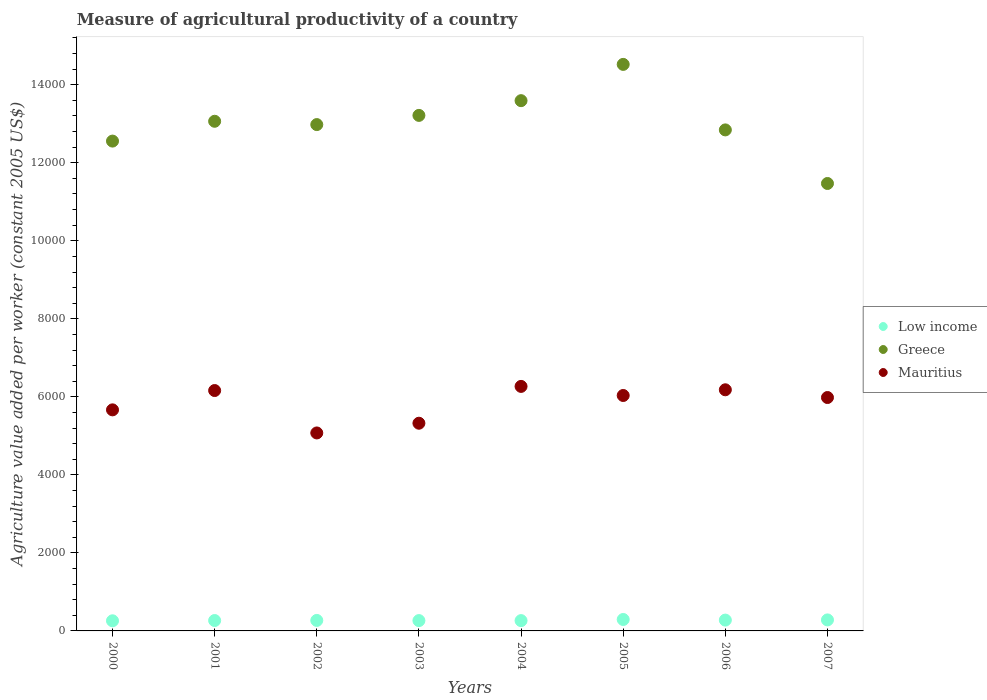How many different coloured dotlines are there?
Provide a succinct answer. 3. What is the measure of agricultural productivity in Low income in 2003?
Your answer should be very brief. 264.83. Across all years, what is the maximum measure of agricultural productivity in Mauritius?
Ensure brevity in your answer.  6267.78. Across all years, what is the minimum measure of agricultural productivity in Mauritius?
Offer a very short reply. 5074.63. In which year was the measure of agricultural productivity in Low income maximum?
Offer a very short reply. 2005. In which year was the measure of agricultural productivity in Mauritius minimum?
Your response must be concise. 2002. What is the total measure of agricultural productivity in Low income in the graph?
Offer a very short reply. 2176.02. What is the difference between the measure of agricultural productivity in Mauritius in 2003 and that in 2004?
Make the answer very short. -943.74. What is the difference between the measure of agricultural productivity in Low income in 2004 and the measure of agricultural productivity in Greece in 2002?
Give a very brief answer. -1.27e+04. What is the average measure of agricultural productivity in Low income per year?
Offer a very short reply. 272. In the year 2004, what is the difference between the measure of agricultural productivity in Mauritius and measure of agricultural productivity in Low income?
Give a very brief answer. 6003.74. What is the ratio of the measure of agricultural productivity in Low income in 2003 to that in 2007?
Give a very brief answer. 0.94. Is the measure of agricultural productivity in Mauritius in 2001 less than that in 2004?
Your answer should be very brief. Yes. Is the difference between the measure of agricultural productivity in Mauritius in 2003 and 2004 greater than the difference between the measure of agricultural productivity in Low income in 2003 and 2004?
Give a very brief answer. No. What is the difference between the highest and the second highest measure of agricultural productivity in Mauritius?
Ensure brevity in your answer.  86.66. What is the difference between the highest and the lowest measure of agricultural productivity in Greece?
Your answer should be very brief. 3052.71. Is the sum of the measure of agricultural productivity in Greece in 2003 and 2006 greater than the maximum measure of agricultural productivity in Mauritius across all years?
Offer a terse response. Yes. Is the measure of agricultural productivity in Low income strictly less than the measure of agricultural productivity in Greece over the years?
Offer a terse response. Yes. How many years are there in the graph?
Provide a short and direct response. 8. Are the values on the major ticks of Y-axis written in scientific E-notation?
Make the answer very short. No. Does the graph contain any zero values?
Offer a terse response. No. Does the graph contain grids?
Provide a succinct answer. No. How are the legend labels stacked?
Ensure brevity in your answer.  Vertical. What is the title of the graph?
Ensure brevity in your answer.  Measure of agricultural productivity of a country. What is the label or title of the Y-axis?
Provide a succinct answer. Agriculture value added per worker (constant 2005 US$). What is the Agriculture value added per worker (constant 2005 US$) of Low income in 2000?
Offer a very short reply. 259.54. What is the Agriculture value added per worker (constant 2005 US$) in Greece in 2000?
Offer a very short reply. 1.26e+04. What is the Agriculture value added per worker (constant 2005 US$) of Mauritius in 2000?
Offer a very short reply. 5666.66. What is the Agriculture value added per worker (constant 2005 US$) in Low income in 2001?
Keep it short and to the point. 266.17. What is the Agriculture value added per worker (constant 2005 US$) of Greece in 2001?
Keep it short and to the point. 1.31e+04. What is the Agriculture value added per worker (constant 2005 US$) in Mauritius in 2001?
Offer a terse response. 6161.82. What is the Agriculture value added per worker (constant 2005 US$) of Low income in 2002?
Your answer should be compact. 268.98. What is the Agriculture value added per worker (constant 2005 US$) in Greece in 2002?
Your response must be concise. 1.30e+04. What is the Agriculture value added per worker (constant 2005 US$) of Mauritius in 2002?
Ensure brevity in your answer.  5074.63. What is the Agriculture value added per worker (constant 2005 US$) of Low income in 2003?
Keep it short and to the point. 264.83. What is the Agriculture value added per worker (constant 2005 US$) of Greece in 2003?
Offer a terse response. 1.32e+04. What is the Agriculture value added per worker (constant 2005 US$) of Mauritius in 2003?
Your response must be concise. 5324.04. What is the Agriculture value added per worker (constant 2005 US$) of Low income in 2004?
Keep it short and to the point. 264.04. What is the Agriculture value added per worker (constant 2005 US$) in Greece in 2004?
Keep it short and to the point. 1.36e+04. What is the Agriculture value added per worker (constant 2005 US$) of Mauritius in 2004?
Give a very brief answer. 6267.78. What is the Agriculture value added per worker (constant 2005 US$) in Low income in 2005?
Make the answer very short. 292.99. What is the Agriculture value added per worker (constant 2005 US$) in Greece in 2005?
Your answer should be very brief. 1.45e+04. What is the Agriculture value added per worker (constant 2005 US$) in Mauritius in 2005?
Keep it short and to the point. 6034.91. What is the Agriculture value added per worker (constant 2005 US$) of Low income in 2006?
Provide a short and direct response. 277.44. What is the Agriculture value added per worker (constant 2005 US$) in Greece in 2006?
Keep it short and to the point. 1.28e+04. What is the Agriculture value added per worker (constant 2005 US$) of Mauritius in 2006?
Make the answer very short. 6181.12. What is the Agriculture value added per worker (constant 2005 US$) of Low income in 2007?
Make the answer very short. 282.02. What is the Agriculture value added per worker (constant 2005 US$) in Greece in 2007?
Ensure brevity in your answer.  1.15e+04. What is the Agriculture value added per worker (constant 2005 US$) of Mauritius in 2007?
Offer a very short reply. 5982.86. Across all years, what is the maximum Agriculture value added per worker (constant 2005 US$) of Low income?
Your response must be concise. 292.99. Across all years, what is the maximum Agriculture value added per worker (constant 2005 US$) of Greece?
Offer a very short reply. 1.45e+04. Across all years, what is the maximum Agriculture value added per worker (constant 2005 US$) of Mauritius?
Your answer should be compact. 6267.78. Across all years, what is the minimum Agriculture value added per worker (constant 2005 US$) of Low income?
Offer a very short reply. 259.54. Across all years, what is the minimum Agriculture value added per worker (constant 2005 US$) of Greece?
Your answer should be compact. 1.15e+04. Across all years, what is the minimum Agriculture value added per worker (constant 2005 US$) of Mauritius?
Offer a very short reply. 5074.63. What is the total Agriculture value added per worker (constant 2005 US$) in Low income in the graph?
Ensure brevity in your answer.  2176.02. What is the total Agriculture value added per worker (constant 2005 US$) in Greece in the graph?
Make the answer very short. 1.04e+05. What is the total Agriculture value added per worker (constant 2005 US$) in Mauritius in the graph?
Keep it short and to the point. 4.67e+04. What is the difference between the Agriculture value added per worker (constant 2005 US$) in Low income in 2000 and that in 2001?
Provide a short and direct response. -6.64. What is the difference between the Agriculture value added per worker (constant 2005 US$) of Greece in 2000 and that in 2001?
Your response must be concise. -507.92. What is the difference between the Agriculture value added per worker (constant 2005 US$) in Mauritius in 2000 and that in 2001?
Offer a very short reply. -495.15. What is the difference between the Agriculture value added per worker (constant 2005 US$) in Low income in 2000 and that in 2002?
Offer a very short reply. -9.45. What is the difference between the Agriculture value added per worker (constant 2005 US$) in Greece in 2000 and that in 2002?
Offer a terse response. -423.05. What is the difference between the Agriculture value added per worker (constant 2005 US$) of Mauritius in 2000 and that in 2002?
Give a very brief answer. 592.03. What is the difference between the Agriculture value added per worker (constant 2005 US$) in Low income in 2000 and that in 2003?
Offer a terse response. -5.3. What is the difference between the Agriculture value added per worker (constant 2005 US$) of Greece in 2000 and that in 2003?
Your response must be concise. -658.71. What is the difference between the Agriculture value added per worker (constant 2005 US$) of Mauritius in 2000 and that in 2003?
Your answer should be very brief. 342.62. What is the difference between the Agriculture value added per worker (constant 2005 US$) in Low income in 2000 and that in 2004?
Offer a terse response. -4.5. What is the difference between the Agriculture value added per worker (constant 2005 US$) in Greece in 2000 and that in 2004?
Offer a very short reply. -1036.19. What is the difference between the Agriculture value added per worker (constant 2005 US$) of Mauritius in 2000 and that in 2004?
Offer a very short reply. -601.12. What is the difference between the Agriculture value added per worker (constant 2005 US$) in Low income in 2000 and that in 2005?
Keep it short and to the point. -33.46. What is the difference between the Agriculture value added per worker (constant 2005 US$) in Greece in 2000 and that in 2005?
Offer a very short reply. -1965.98. What is the difference between the Agriculture value added per worker (constant 2005 US$) of Mauritius in 2000 and that in 2005?
Your answer should be very brief. -368.25. What is the difference between the Agriculture value added per worker (constant 2005 US$) of Low income in 2000 and that in 2006?
Provide a short and direct response. -17.9. What is the difference between the Agriculture value added per worker (constant 2005 US$) of Greece in 2000 and that in 2006?
Offer a very short reply. -286.79. What is the difference between the Agriculture value added per worker (constant 2005 US$) in Mauritius in 2000 and that in 2006?
Offer a terse response. -514.46. What is the difference between the Agriculture value added per worker (constant 2005 US$) in Low income in 2000 and that in 2007?
Your answer should be compact. -22.49. What is the difference between the Agriculture value added per worker (constant 2005 US$) in Greece in 2000 and that in 2007?
Your answer should be compact. 1086.73. What is the difference between the Agriculture value added per worker (constant 2005 US$) in Mauritius in 2000 and that in 2007?
Give a very brief answer. -316.19. What is the difference between the Agriculture value added per worker (constant 2005 US$) in Low income in 2001 and that in 2002?
Provide a succinct answer. -2.81. What is the difference between the Agriculture value added per worker (constant 2005 US$) of Greece in 2001 and that in 2002?
Provide a short and direct response. 84.86. What is the difference between the Agriculture value added per worker (constant 2005 US$) in Mauritius in 2001 and that in 2002?
Keep it short and to the point. 1087.19. What is the difference between the Agriculture value added per worker (constant 2005 US$) of Low income in 2001 and that in 2003?
Offer a terse response. 1.34. What is the difference between the Agriculture value added per worker (constant 2005 US$) in Greece in 2001 and that in 2003?
Offer a terse response. -150.79. What is the difference between the Agriculture value added per worker (constant 2005 US$) of Mauritius in 2001 and that in 2003?
Give a very brief answer. 837.77. What is the difference between the Agriculture value added per worker (constant 2005 US$) of Low income in 2001 and that in 2004?
Your response must be concise. 2.13. What is the difference between the Agriculture value added per worker (constant 2005 US$) of Greece in 2001 and that in 2004?
Ensure brevity in your answer.  -528.27. What is the difference between the Agriculture value added per worker (constant 2005 US$) in Mauritius in 2001 and that in 2004?
Keep it short and to the point. -105.96. What is the difference between the Agriculture value added per worker (constant 2005 US$) of Low income in 2001 and that in 2005?
Offer a very short reply. -26.82. What is the difference between the Agriculture value added per worker (constant 2005 US$) of Greece in 2001 and that in 2005?
Provide a succinct answer. -1458.06. What is the difference between the Agriculture value added per worker (constant 2005 US$) in Mauritius in 2001 and that in 2005?
Ensure brevity in your answer.  126.91. What is the difference between the Agriculture value added per worker (constant 2005 US$) of Low income in 2001 and that in 2006?
Provide a succinct answer. -11.27. What is the difference between the Agriculture value added per worker (constant 2005 US$) in Greece in 2001 and that in 2006?
Ensure brevity in your answer.  221.12. What is the difference between the Agriculture value added per worker (constant 2005 US$) in Mauritius in 2001 and that in 2006?
Keep it short and to the point. -19.3. What is the difference between the Agriculture value added per worker (constant 2005 US$) of Low income in 2001 and that in 2007?
Your answer should be compact. -15.85. What is the difference between the Agriculture value added per worker (constant 2005 US$) of Greece in 2001 and that in 2007?
Make the answer very short. 1594.65. What is the difference between the Agriculture value added per worker (constant 2005 US$) of Mauritius in 2001 and that in 2007?
Give a very brief answer. 178.96. What is the difference between the Agriculture value added per worker (constant 2005 US$) in Low income in 2002 and that in 2003?
Your response must be concise. 4.15. What is the difference between the Agriculture value added per worker (constant 2005 US$) in Greece in 2002 and that in 2003?
Provide a short and direct response. -235.66. What is the difference between the Agriculture value added per worker (constant 2005 US$) in Mauritius in 2002 and that in 2003?
Provide a succinct answer. -249.41. What is the difference between the Agriculture value added per worker (constant 2005 US$) in Low income in 2002 and that in 2004?
Ensure brevity in your answer.  4.94. What is the difference between the Agriculture value added per worker (constant 2005 US$) of Greece in 2002 and that in 2004?
Your response must be concise. -613.14. What is the difference between the Agriculture value added per worker (constant 2005 US$) in Mauritius in 2002 and that in 2004?
Provide a short and direct response. -1193.15. What is the difference between the Agriculture value added per worker (constant 2005 US$) of Low income in 2002 and that in 2005?
Provide a short and direct response. -24.01. What is the difference between the Agriculture value added per worker (constant 2005 US$) in Greece in 2002 and that in 2005?
Ensure brevity in your answer.  -1542.93. What is the difference between the Agriculture value added per worker (constant 2005 US$) in Mauritius in 2002 and that in 2005?
Make the answer very short. -960.28. What is the difference between the Agriculture value added per worker (constant 2005 US$) of Low income in 2002 and that in 2006?
Give a very brief answer. -8.45. What is the difference between the Agriculture value added per worker (constant 2005 US$) in Greece in 2002 and that in 2006?
Your answer should be very brief. 136.26. What is the difference between the Agriculture value added per worker (constant 2005 US$) of Mauritius in 2002 and that in 2006?
Make the answer very short. -1106.49. What is the difference between the Agriculture value added per worker (constant 2005 US$) of Low income in 2002 and that in 2007?
Give a very brief answer. -13.04. What is the difference between the Agriculture value added per worker (constant 2005 US$) of Greece in 2002 and that in 2007?
Provide a short and direct response. 1509.79. What is the difference between the Agriculture value added per worker (constant 2005 US$) in Mauritius in 2002 and that in 2007?
Offer a terse response. -908.23. What is the difference between the Agriculture value added per worker (constant 2005 US$) of Low income in 2003 and that in 2004?
Provide a short and direct response. 0.79. What is the difference between the Agriculture value added per worker (constant 2005 US$) of Greece in 2003 and that in 2004?
Provide a succinct answer. -377.48. What is the difference between the Agriculture value added per worker (constant 2005 US$) in Mauritius in 2003 and that in 2004?
Offer a very short reply. -943.74. What is the difference between the Agriculture value added per worker (constant 2005 US$) of Low income in 2003 and that in 2005?
Provide a succinct answer. -28.16. What is the difference between the Agriculture value added per worker (constant 2005 US$) of Greece in 2003 and that in 2005?
Provide a succinct answer. -1307.27. What is the difference between the Agriculture value added per worker (constant 2005 US$) of Mauritius in 2003 and that in 2005?
Provide a succinct answer. -710.87. What is the difference between the Agriculture value added per worker (constant 2005 US$) of Low income in 2003 and that in 2006?
Your response must be concise. -12.6. What is the difference between the Agriculture value added per worker (constant 2005 US$) in Greece in 2003 and that in 2006?
Provide a succinct answer. 371.91. What is the difference between the Agriculture value added per worker (constant 2005 US$) in Mauritius in 2003 and that in 2006?
Ensure brevity in your answer.  -857.08. What is the difference between the Agriculture value added per worker (constant 2005 US$) in Low income in 2003 and that in 2007?
Provide a short and direct response. -17.19. What is the difference between the Agriculture value added per worker (constant 2005 US$) of Greece in 2003 and that in 2007?
Keep it short and to the point. 1745.44. What is the difference between the Agriculture value added per worker (constant 2005 US$) of Mauritius in 2003 and that in 2007?
Your answer should be compact. -658.81. What is the difference between the Agriculture value added per worker (constant 2005 US$) in Low income in 2004 and that in 2005?
Offer a very short reply. -28.95. What is the difference between the Agriculture value added per worker (constant 2005 US$) of Greece in 2004 and that in 2005?
Provide a short and direct response. -929.79. What is the difference between the Agriculture value added per worker (constant 2005 US$) of Mauritius in 2004 and that in 2005?
Provide a short and direct response. 232.87. What is the difference between the Agriculture value added per worker (constant 2005 US$) in Low income in 2004 and that in 2006?
Offer a very short reply. -13.4. What is the difference between the Agriculture value added per worker (constant 2005 US$) of Greece in 2004 and that in 2006?
Offer a very short reply. 749.4. What is the difference between the Agriculture value added per worker (constant 2005 US$) in Mauritius in 2004 and that in 2006?
Make the answer very short. 86.66. What is the difference between the Agriculture value added per worker (constant 2005 US$) in Low income in 2004 and that in 2007?
Ensure brevity in your answer.  -17.98. What is the difference between the Agriculture value added per worker (constant 2005 US$) in Greece in 2004 and that in 2007?
Your answer should be very brief. 2122.92. What is the difference between the Agriculture value added per worker (constant 2005 US$) in Mauritius in 2004 and that in 2007?
Your answer should be very brief. 284.92. What is the difference between the Agriculture value added per worker (constant 2005 US$) in Low income in 2005 and that in 2006?
Provide a succinct answer. 15.56. What is the difference between the Agriculture value added per worker (constant 2005 US$) in Greece in 2005 and that in 2006?
Your response must be concise. 1679.19. What is the difference between the Agriculture value added per worker (constant 2005 US$) of Mauritius in 2005 and that in 2006?
Your answer should be compact. -146.21. What is the difference between the Agriculture value added per worker (constant 2005 US$) of Low income in 2005 and that in 2007?
Offer a very short reply. 10.97. What is the difference between the Agriculture value added per worker (constant 2005 US$) in Greece in 2005 and that in 2007?
Offer a terse response. 3052.71. What is the difference between the Agriculture value added per worker (constant 2005 US$) in Mauritius in 2005 and that in 2007?
Offer a very short reply. 52.05. What is the difference between the Agriculture value added per worker (constant 2005 US$) in Low income in 2006 and that in 2007?
Your answer should be very brief. -4.59. What is the difference between the Agriculture value added per worker (constant 2005 US$) of Greece in 2006 and that in 2007?
Provide a short and direct response. 1373.53. What is the difference between the Agriculture value added per worker (constant 2005 US$) of Mauritius in 2006 and that in 2007?
Your response must be concise. 198.26. What is the difference between the Agriculture value added per worker (constant 2005 US$) of Low income in 2000 and the Agriculture value added per worker (constant 2005 US$) of Greece in 2001?
Give a very brief answer. -1.28e+04. What is the difference between the Agriculture value added per worker (constant 2005 US$) of Low income in 2000 and the Agriculture value added per worker (constant 2005 US$) of Mauritius in 2001?
Your response must be concise. -5902.28. What is the difference between the Agriculture value added per worker (constant 2005 US$) of Greece in 2000 and the Agriculture value added per worker (constant 2005 US$) of Mauritius in 2001?
Keep it short and to the point. 6394.2. What is the difference between the Agriculture value added per worker (constant 2005 US$) in Low income in 2000 and the Agriculture value added per worker (constant 2005 US$) in Greece in 2002?
Your response must be concise. -1.27e+04. What is the difference between the Agriculture value added per worker (constant 2005 US$) of Low income in 2000 and the Agriculture value added per worker (constant 2005 US$) of Mauritius in 2002?
Keep it short and to the point. -4815.09. What is the difference between the Agriculture value added per worker (constant 2005 US$) of Greece in 2000 and the Agriculture value added per worker (constant 2005 US$) of Mauritius in 2002?
Make the answer very short. 7481.38. What is the difference between the Agriculture value added per worker (constant 2005 US$) in Low income in 2000 and the Agriculture value added per worker (constant 2005 US$) in Greece in 2003?
Give a very brief answer. -1.30e+04. What is the difference between the Agriculture value added per worker (constant 2005 US$) of Low income in 2000 and the Agriculture value added per worker (constant 2005 US$) of Mauritius in 2003?
Your response must be concise. -5064.51. What is the difference between the Agriculture value added per worker (constant 2005 US$) in Greece in 2000 and the Agriculture value added per worker (constant 2005 US$) in Mauritius in 2003?
Keep it short and to the point. 7231.97. What is the difference between the Agriculture value added per worker (constant 2005 US$) in Low income in 2000 and the Agriculture value added per worker (constant 2005 US$) in Greece in 2004?
Make the answer very short. -1.33e+04. What is the difference between the Agriculture value added per worker (constant 2005 US$) in Low income in 2000 and the Agriculture value added per worker (constant 2005 US$) in Mauritius in 2004?
Offer a terse response. -6008.25. What is the difference between the Agriculture value added per worker (constant 2005 US$) in Greece in 2000 and the Agriculture value added per worker (constant 2005 US$) in Mauritius in 2004?
Keep it short and to the point. 6288.23. What is the difference between the Agriculture value added per worker (constant 2005 US$) in Low income in 2000 and the Agriculture value added per worker (constant 2005 US$) in Greece in 2005?
Keep it short and to the point. -1.43e+04. What is the difference between the Agriculture value added per worker (constant 2005 US$) in Low income in 2000 and the Agriculture value added per worker (constant 2005 US$) in Mauritius in 2005?
Keep it short and to the point. -5775.37. What is the difference between the Agriculture value added per worker (constant 2005 US$) of Greece in 2000 and the Agriculture value added per worker (constant 2005 US$) of Mauritius in 2005?
Keep it short and to the point. 6521.1. What is the difference between the Agriculture value added per worker (constant 2005 US$) of Low income in 2000 and the Agriculture value added per worker (constant 2005 US$) of Greece in 2006?
Keep it short and to the point. -1.26e+04. What is the difference between the Agriculture value added per worker (constant 2005 US$) of Low income in 2000 and the Agriculture value added per worker (constant 2005 US$) of Mauritius in 2006?
Your answer should be compact. -5921.58. What is the difference between the Agriculture value added per worker (constant 2005 US$) in Greece in 2000 and the Agriculture value added per worker (constant 2005 US$) in Mauritius in 2006?
Give a very brief answer. 6374.89. What is the difference between the Agriculture value added per worker (constant 2005 US$) in Low income in 2000 and the Agriculture value added per worker (constant 2005 US$) in Greece in 2007?
Offer a very short reply. -1.12e+04. What is the difference between the Agriculture value added per worker (constant 2005 US$) of Low income in 2000 and the Agriculture value added per worker (constant 2005 US$) of Mauritius in 2007?
Make the answer very short. -5723.32. What is the difference between the Agriculture value added per worker (constant 2005 US$) of Greece in 2000 and the Agriculture value added per worker (constant 2005 US$) of Mauritius in 2007?
Make the answer very short. 6573.16. What is the difference between the Agriculture value added per worker (constant 2005 US$) in Low income in 2001 and the Agriculture value added per worker (constant 2005 US$) in Greece in 2002?
Your response must be concise. -1.27e+04. What is the difference between the Agriculture value added per worker (constant 2005 US$) in Low income in 2001 and the Agriculture value added per worker (constant 2005 US$) in Mauritius in 2002?
Offer a very short reply. -4808.46. What is the difference between the Agriculture value added per worker (constant 2005 US$) in Greece in 2001 and the Agriculture value added per worker (constant 2005 US$) in Mauritius in 2002?
Your response must be concise. 7989.3. What is the difference between the Agriculture value added per worker (constant 2005 US$) in Low income in 2001 and the Agriculture value added per worker (constant 2005 US$) in Greece in 2003?
Give a very brief answer. -1.29e+04. What is the difference between the Agriculture value added per worker (constant 2005 US$) of Low income in 2001 and the Agriculture value added per worker (constant 2005 US$) of Mauritius in 2003?
Your answer should be compact. -5057.87. What is the difference between the Agriculture value added per worker (constant 2005 US$) in Greece in 2001 and the Agriculture value added per worker (constant 2005 US$) in Mauritius in 2003?
Your response must be concise. 7739.89. What is the difference between the Agriculture value added per worker (constant 2005 US$) in Low income in 2001 and the Agriculture value added per worker (constant 2005 US$) in Greece in 2004?
Offer a very short reply. -1.33e+04. What is the difference between the Agriculture value added per worker (constant 2005 US$) of Low income in 2001 and the Agriculture value added per worker (constant 2005 US$) of Mauritius in 2004?
Provide a short and direct response. -6001.61. What is the difference between the Agriculture value added per worker (constant 2005 US$) in Greece in 2001 and the Agriculture value added per worker (constant 2005 US$) in Mauritius in 2004?
Your response must be concise. 6796.15. What is the difference between the Agriculture value added per worker (constant 2005 US$) in Low income in 2001 and the Agriculture value added per worker (constant 2005 US$) in Greece in 2005?
Your response must be concise. -1.43e+04. What is the difference between the Agriculture value added per worker (constant 2005 US$) of Low income in 2001 and the Agriculture value added per worker (constant 2005 US$) of Mauritius in 2005?
Keep it short and to the point. -5768.74. What is the difference between the Agriculture value added per worker (constant 2005 US$) in Greece in 2001 and the Agriculture value added per worker (constant 2005 US$) in Mauritius in 2005?
Your answer should be compact. 7029.02. What is the difference between the Agriculture value added per worker (constant 2005 US$) of Low income in 2001 and the Agriculture value added per worker (constant 2005 US$) of Greece in 2006?
Give a very brief answer. -1.26e+04. What is the difference between the Agriculture value added per worker (constant 2005 US$) in Low income in 2001 and the Agriculture value added per worker (constant 2005 US$) in Mauritius in 2006?
Keep it short and to the point. -5914.95. What is the difference between the Agriculture value added per worker (constant 2005 US$) of Greece in 2001 and the Agriculture value added per worker (constant 2005 US$) of Mauritius in 2006?
Provide a succinct answer. 6882.81. What is the difference between the Agriculture value added per worker (constant 2005 US$) of Low income in 2001 and the Agriculture value added per worker (constant 2005 US$) of Greece in 2007?
Your answer should be very brief. -1.12e+04. What is the difference between the Agriculture value added per worker (constant 2005 US$) of Low income in 2001 and the Agriculture value added per worker (constant 2005 US$) of Mauritius in 2007?
Keep it short and to the point. -5716.69. What is the difference between the Agriculture value added per worker (constant 2005 US$) in Greece in 2001 and the Agriculture value added per worker (constant 2005 US$) in Mauritius in 2007?
Provide a short and direct response. 7081.07. What is the difference between the Agriculture value added per worker (constant 2005 US$) in Low income in 2002 and the Agriculture value added per worker (constant 2005 US$) in Greece in 2003?
Ensure brevity in your answer.  -1.29e+04. What is the difference between the Agriculture value added per worker (constant 2005 US$) in Low income in 2002 and the Agriculture value added per worker (constant 2005 US$) in Mauritius in 2003?
Keep it short and to the point. -5055.06. What is the difference between the Agriculture value added per worker (constant 2005 US$) of Greece in 2002 and the Agriculture value added per worker (constant 2005 US$) of Mauritius in 2003?
Offer a very short reply. 7655.02. What is the difference between the Agriculture value added per worker (constant 2005 US$) in Low income in 2002 and the Agriculture value added per worker (constant 2005 US$) in Greece in 2004?
Provide a succinct answer. -1.33e+04. What is the difference between the Agriculture value added per worker (constant 2005 US$) of Low income in 2002 and the Agriculture value added per worker (constant 2005 US$) of Mauritius in 2004?
Offer a very short reply. -5998.8. What is the difference between the Agriculture value added per worker (constant 2005 US$) of Greece in 2002 and the Agriculture value added per worker (constant 2005 US$) of Mauritius in 2004?
Your answer should be compact. 6711.28. What is the difference between the Agriculture value added per worker (constant 2005 US$) of Low income in 2002 and the Agriculture value added per worker (constant 2005 US$) of Greece in 2005?
Your answer should be compact. -1.43e+04. What is the difference between the Agriculture value added per worker (constant 2005 US$) in Low income in 2002 and the Agriculture value added per worker (constant 2005 US$) in Mauritius in 2005?
Your response must be concise. -5765.93. What is the difference between the Agriculture value added per worker (constant 2005 US$) in Greece in 2002 and the Agriculture value added per worker (constant 2005 US$) in Mauritius in 2005?
Keep it short and to the point. 6944.15. What is the difference between the Agriculture value added per worker (constant 2005 US$) of Low income in 2002 and the Agriculture value added per worker (constant 2005 US$) of Greece in 2006?
Provide a succinct answer. -1.26e+04. What is the difference between the Agriculture value added per worker (constant 2005 US$) of Low income in 2002 and the Agriculture value added per worker (constant 2005 US$) of Mauritius in 2006?
Offer a terse response. -5912.14. What is the difference between the Agriculture value added per worker (constant 2005 US$) in Greece in 2002 and the Agriculture value added per worker (constant 2005 US$) in Mauritius in 2006?
Keep it short and to the point. 6797.94. What is the difference between the Agriculture value added per worker (constant 2005 US$) in Low income in 2002 and the Agriculture value added per worker (constant 2005 US$) in Greece in 2007?
Provide a succinct answer. -1.12e+04. What is the difference between the Agriculture value added per worker (constant 2005 US$) in Low income in 2002 and the Agriculture value added per worker (constant 2005 US$) in Mauritius in 2007?
Make the answer very short. -5713.87. What is the difference between the Agriculture value added per worker (constant 2005 US$) in Greece in 2002 and the Agriculture value added per worker (constant 2005 US$) in Mauritius in 2007?
Give a very brief answer. 6996.21. What is the difference between the Agriculture value added per worker (constant 2005 US$) of Low income in 2003 and the Agriculture value added per worker (constant 2005 US$) of Greece in 2004?
Your answer should be compact. -1.33e+04. What is the difference between the Agriculture value added per worker (constant 2005 US$) of Low income in 2003 and the Agriculture value added per worker (constant 2005 US$) of Mauritius in 2004?
Make the answer very short. -6002.95. What is the difference between the Agriculture value added per worker (constant 2005 US$) of Greece in 2003 and the Agriculture value added per worker (constant 2005 US$) of Mauritius in 2004?
Provide a succinct answer. 6946.94. What is the difference between the Agriculture value added per worker (constant 2005 US$) in Low income in 2003 and the Agriculture value added per worker (constant 2005 US$) in Greece in 2005?
Make the answer very short. -1.43e+04. What is the difference between the Agriculture value added per worker (constant 2005 US$) in Low income in 2003 and the Agriculture value added per worker (constant 2005 US$) in Mauritius in 2005?
Provide a succinct answer. -5770.08. What is the difference between the Agriculture value added per worker (constant 2005 US$) in Greece in 2003 and the Agriculture value added per worker (constant 2005 US$) in Mauritius in 2005?
Your response must be concise. 7179.81. What is the difference between the Agriculture value added per worker (constant 2005 US$) in Low income in 2003 and the Agriculture value added per worker (constant 2005 US$) in Greece in 2006?
Provide a short and direct response. -1.26e+04. What is the difference between the Agriculture value added per worker (constant 2005 US$) in Low income in 2003 and the Agriculture value added per worker (constant 2005 US$) in Mauritius in 2006?
Offer a terse response. -5916.29. What is the difference between the Agriculture value added per worker (constant 2005 US$) in Greece in 2003 and the Agriculture value added per worker (constant 2005 US$) in Mauritius in 2006?
Ensure brevity in your answer.  7033.6. What is the difference between the Agriculture value added per worker (constant 2005 US$) in Low income in 2003 and the Agriculture value added per worker (constant 2005 US$) in Greece in 2007?
Your answer should be very brief. -1.12e+04. What is the difference between the Agriculture value added per worker (constant 2005 US$) in Low income in 2003 and the Agriculture value added per worker (constant 2005 US$) in Mauritius in 2007?
Your answer should be very brief. -5718.02. What is the difference between the Agriculture value added per worker (constant 2005 US$) in Greece in 2003 and the Agriculture value added per worker (constant 2005 US$) in Mauritius in 2007?
Offer a terse response. 7231.86. What is the difference between the Agriculture value added per worker (constant 2005 US$) of Low income in 2004 and the Agriculture value added per worker (constant 2005 US$) of Greece in 2005?
Keep it short and to the point. -1.43e+04. What is the difference between the Agriculture value added per worker (constant 2005 US$) of Low income in 2004 and the Agriculture value added per worker (constant 2005 US$) of Mauritius in 2005?
Offer a terse response. -5770.87. What is the difference between the Agriculture value added per worker (constant 2005 US$) of Greece in 2004 and the Agriculture value added per worker (constant 2005 US$) of Mauritius in 2005?
Provide a short and direct response. 7557.29. What is the difference between the Agriculture value added per worker (constant 2005 US$) in Low income in 2004 and the Agriculture value added per worker (constant 2005 US$) in Greece in 2006?
Ensure brevity in your answer.  -1.26e+04. What is the difference between the Agriculture value added per worker (constant 2005 US$) of Low income in 2004 and the Agriculture value added per worker (constant 2005 US$) of Mauritius in 2006?
Ensure brevity in your answer.  -5917.08. What is the difference between the Agriculture value added per worker (constant 2005 US$) of Greece in 2004 and the Agriculture value added per worker (constant 2005 US$) of Mauritius in 2006?
Your answer should be compact. 7411.08. What is the difference between the Agriculture value added per worker (constant 2005 US$) of Low income in 2004 and the Agriculture value added per worker (constant 2005 US$) of Greece in 2007?
Keep it short and to the point. -1.12e+04. What is the difference between the Agriculture value added per worker (constant 2005 US$) in Low income in 2004 and the Agriculture value added per worker (constant 2005 US$) in Mauritius in 2007?
Keep it short and to the point. -5718.82. What is the difference between the Agriculture value added per worker (constant 2005 US$) of Greece in 2004 and the Agriculture value added per worker (constant 2005 US$) of Mauritius in 2007?
Offer a terse response. 7609.35. What is the difference between the Agriculture value added per worker (constant 2005 US$) of Low income in 2005 and the Agriculture value added per worker (constant 2005 US$) of Greece in 2006?
Offer a terse response. -1.25e+04. What is the difference between the Agriculture value added per worker (constant 2005 US$) in Low income in 2005 and the Agriculture value added per worker (constant 2005 US$) in Mauritius in 2006?
Your response must be concise. -5888.13. What is the difference between the Agriculture value added per worker (constant 2005 US$) of Greece in 2005 and the Agriculture value added per worker (constant 2005 US$) of Mauritius in 2006?
Ensure brevity in your answer.  8340.87. What is the difference between the Agriculture value added per worker (constant 2005 US$) in Low income in 2005 and the Agriculture value added per worker (constant 2005 US$) in Greece in 2007?
Provide a succinct answer. -1.12e+04. What is the difference between the Agriculture value added per worker (constant 2005 US$) of Low income in 2005 and the Agriculture value added per worker (constant 2005 US$) of Mauritius in 2007?
Give a very brief answer. -5689.86. What is the difference between the Agriculture value added per worker (constant 2005 US$) of Greece in 2005 and the Agriculture value added per worker (constant 2005 US$) of Mauritius in 2007?
Make the answer very short. 8539.14. What is the difference between the Agriculture value added per worker (constant 2005 US$) of Low income in 2006 and the Agriculture value added per worker (constant 2005 US$) of Greece in 2007?
Make the answer very short. -1.12e+04. What is the difference between the Agriculture value added per worker (constant 2005 US$) of Low income in 2006 and the Agriculture value added per worker (constant 2005 US$) of Mauritius in 2007?
Your response must be concise. -5705.42. What is the difference between the Agriculture value added per worker (constant 2005 US$) in Greece in 2006 and the Agriculture value added per worker (constant 2005 US$) in Mauritius in 2007?
Your answer should be compact. 6859.95. What is the average Agriculture value added per worker (constant 2005 US$) of Low income per year?
Provide a short and direct response. 272. What is the average Agriculture value added per worker (constant 2005 US$) of Greece per year?
Provide a short and direct response. 1.30e+04. What is the average Agriculture value added per worker (constant 2005 US$) in Mauritius per year?
Your answer should be compact. 5836.73. In the year 2000, what is the difference between the Agriculture value added per worker (constant 2005 US$) of Low income and Agriculture value added per worker (constant 2005 US$) of Greece?
Your answer should be compact. -1.23e+04. In the year 2000, what is the difference between the Agriculture value added per worker (constant 2005 US$) in Low income and Agriculture value added per worker (constant 2005 US$) in Mauritius?
Provide a succinct answer. -5407.13. In the year 2000, what is the difference between the Agriculture value added per worker (constant 2005 US$) in Greece and Agriculture value added per worker (constant 2005 US$) in Mauritius?
Provide a short and direct response. 6889.35. In the year 2001, what is the difference between the Agriculture value added per worker (constant 2005 US$) of Low income and Agriculture value added per worker (constant 2005 US$) of Greece?
Keep it short and to the point. -1.28e+04. In the year 2001, what is the difference between the Agriculture value added per worker (constant 2005 US$) of Low income and Agriculture value added per worker (constant 2005 US$) of Mauritius?
Provide a succinct answer. -5895.64. In the year 2001, what is the difference between the Agriculture value added per worker (constant 2005 US$) in Greece and Agriculture value added per worker (constant 2005 US$) in Mauritius?
Make the answer very short. 6902.11. In the year 2002, what is the difference between the Agriculture value added per worker (constant 2005 US$) of Low income and Agriculture value added per worker (constant 2005 US$) of Greece?
Make the answer very short. -1.27e+04. In the year 2002, what is the difference between the Agriculture value added per worker (constant 2005 US$) of Low income and Agriculture value added per worker (constant 2005 US$) of Mauritius?
Give a very brief answer. -4805.65. In the year 2002, what is the difference between the Agriculture value added per worker (constant 2005 US$) in Greece and Agriculture value added per worker (constant 2005 US$) in Mauritius?
Make the answer very short. 7904.43. In the year 2003, what is the difference between the Agriculture value added per worker (constant 2005 US$) in Low income and Agriculture value added per worker (constant 2005 US$) in Greece?
Offer a very short reply. -1.29e+04. In the year 2003, what is the difference between the Agriculture value added per worker (constant 2005 US$) of Low income and Agriculture value added per worker (constant 2005 US$) of Mauritius?
Ensure brevity in your answer.  -5059.21. In the year 2003, what is the difference between the Agriculture value added per worker (constant 2005 US$) in Greece and Agriculture value added per worker (constant 2005 US$) in Mauritius?
Provide a short and direct response. 7890.68. In the year 2004, what is the difference between the Agriculture value added per worker (constant 2005 US$) of Low income and Agriculture value added per worker (constant 2005 US$) of Greece?
Offer a terse response. -1.33e+04. In the year 2004, what is the difference between the Agriculture value added per worker (constant 2005 US$) in Low income and Agriculture value added per worker (constant 2005 US$) in Mauritius?
Make the answer very short. -6003.74. In the year 2004, what is the difference between the Agriculture value added per worker (constant 2005 US$) of Greece and Agriculture value added per worker (constant 2005 US$) of Mauritius?
Give a very brief answer. 7324.42. In the year 2005, what is the difference between the Agriculture value added per worker (constant 2005 US$) in Low income and Agriculture value added per worker (constant 2005 US$) in Greece?
Give a very brief answer. -1.42e+04. In the year 2005, what is the difference between the Agriculture value added per worker (constant 2005 US$) in Low income and Agriculture value added per worker (constant 2005 US$) in Mauritius?
Provide a short and direct response. -5741.92. In the year 2005, what is the difference between the Agriculture value added per worker (constant 2005 US$) in Greece and Agriculture value added per worker (constant 2005 US$) in Mauritius?
Make the answer very short. 8487.08. In the year 2006, what is the difference between the Agriculture value added per worker (constant 2005 US$) in Low income and Agriculture value added per worker (constant 2005 US$) in Greece?
Ensure brevity in your answer.  -1.26e+04. In the year 2006, what is the difference between the Agriculture value added per worker (constant 2005 US$) in Low income and Agriculture value added per worker (constant 2005 US$) in Mauritius?
Ensure brevity in your answer.  -5903.68. In the year 2006, what is the difference between the Agriculture value added per worker (constant 2005 US$) in Greece and Agriculture value added per worker (constant 2005 US$) in Mauritius?
Provide a short and direct response. 6661.69. In the year 2007, what is the difference between the Agriculture value added per worker (constant 2005 US$) of Low income and Agriculture value added per worker (constant 2005 US$) of Greece?
Make the answer very short. -1.12e+04. In the year 2007, what is the difference between the Agriculture value added per worker (constant 2005 US$) in Low income and Agriculture value added per worker (constant 2005 US$) in Mauritius?
Provide a short and direct response. -5700.83. In the year 2007, what is the difference between the Agriculture value added per worker (constant 2005 US$) of Greece and Agriculture value added per worker (constant 2005 US$) of Mauritius?
Keep it short and to the point. 5486.42. What is the ratio of the Agriculture value added per worker (constant 2005 US$) in Low income in 2000 to that in 2001?
Provide a succinct answer. 0.98. What is the ratio of the Agriculture value added per worker (constant 2005 US$) of Greece in 2000 to that in 2001?
Provide a short and direct response. 0.96. What is the ratio of the Agriculture value added per worker (constant 2005 US$) of Mauritius in 2000 to that in 2001?
Ensure brevity in your answer.  0.92. What is the ratio of the Agriculture value added per worker (constant 2005 US$) in Low income in 2000 to that in 2002?
Provide a short and direct response. 0.96. What is the ratio of the Agriculture value added per worker (constant 2005 US$) of Greece in 2000 to that in 2002?
Your answer should be compact. 0.97. What is the ratio of the Agriculture value added per worker (constant 2005 US$) of Mauritius in 2000 to that in 2002?
Your answer should be compact. 1.12. What is the ratio of the Agriculture value added per worker (constant 2005 US$) of Greece in 2000 to that in 2003?
Your answer should be very brief. 0.95. What is the ratio of the Agriculture value added per worker (constant 2005 US$) of Mauritius in 2000 to that in 2003?
Give a very brief answer. 1.06. What is the ratio of the Agriculture value added per worker (constant 2005 US$) in Low income in 2000 to that in 2004?
Provide a succinct answer. 0.98. What is the ratio of the Agriculture value added per worker (constant 2005 US$) of Greece in 2000 to that in 2004?
Offer a very short reply. 0.92. What is the ratio of the Agriculture value added per worker (constant 2005 US$) of Mauritius in 2000 to that in 2004?
Your answer should be very brief. 0.9. What is the ratio of the Agriculture value added per worker (constant 2005 US$) in Low income in 2000 to that in 2005?
Provide a short and direct response. 0.89. What is the ratio of the Agriculture value added per worker (constant 2005 US$) of Greece in 2000 to that in 2005?
Your answer should be very brief. 0.86. What is the ratio of the Agriculture value added per worker (constant 2005 US$) in Mauritius in 2000 to that in 2005?
Your response must be concise. 0.94. What is the ratio of the Agriculture value added per worker (constant 2005 US$) in Low income in 2000 to that in 2006?
Provide a succinct answer. 0.94. What is the ratio of the Agriculture value added per worker (constant 2005 US$) of Greece in 2000 to that in 2006?
Provide a succinct answer. 0.98. What is the ratio of the Agriculture value added per worker (constant 2005 US$) of Mauritius in 2000 to that in 2006?
Give a very brief answer. 0.92. What is the ratio of the Agriculture value added per worker (constant 2005 US$) in Low income in 2000 to that in 2007?
Provide a succinct answer. 0.92. What is the ratio of the Agriculture value added per worker (constant 2005 US$) in Greece in 2000 to that in 2007?
Provide a succinct answer. 1.09. What is the ratio of the Agriculture value added per worker (constant 2005 US$) in Mauritius in 2000 to that in 2007?
Provide a short and direct response. 0.95. What is the ratio of the Agriculture value added per worker (constant 2005 US$) of Greece in 2001 to that in 2002?
Ensure brevity in your answer.  1.01. What is the ratio of the Agriculture value added per worker (constant 2005 US$) of Mauritius in 2001 to that in 2002?
Your response must be concise. 1.21. What is the ratio of the Agriculture value added per worker (constant 2005 US$) in Greece in 2001 to that in 2003?
Your answer should be very brief. 0.99. What is the ratio of the Agriculture value added per worker (constant 2005 US$) in Mauritius in 2001 to that in 2003?
Your response must be concise. 1.16. What is the ratio of the Agriculture value added per worker (constant 2005 US$) of Greece in 2001 to that in 2004?
Provide a succinct answer. 0.96. What is the ratio of the Agriculture value added per worker (constant 2005 US$) of Mauritius in 2001 to that in 2004?
Offer a terse response. 0.98. What is the ratio of the Agriculture value added per worker (constant 2005 US$) in Low income in 2001 to that in 2005?
Keep it short and to the point. 0.91. What is the ratio of the Agriculture value added per worker (constant 2005 US$) in Greece in 2001 to that in 2005?
Your answer should be compact. 0.9. What is the ratio of the Agriculture value added per worker (constant 2005 US$) in Mauritius in 2001 to that in 2005?
Provide a succinct answer. 1.02. What is the ratio of the Agriculture value added per worker (constant 2005 US$) in Low income in 2001 to that in 2006?
Give a very brief answer. 0.96. What is the ratio of the Agriculture value added per worker (constant 2005 US$) in Greece in 2001 to that in 2006?
Your answer should be compact. 1.02. What is the ratio of the Agriculture value added per worker (constant 2005 US$) in Low income in 2001 to that in 2007?
Ensure brevity in your answer.  0.94. What is the ratio of the Agriculture value added per worker (constant 2005 US$) in Greece in 2001 to that in 2007?
Your response must be concise. 1.14. What is the ratio of the Agriculture value added per worker (constant 2005 US$) of Mauritius in 2001 to that in 2007?
Your answer should be compact. 1.03. What is the ratio of the Agriculture value added per worker (constant 2005 US$) of Low income in 2002 to that in 2003?
Make the answer very short. 1.02. What is the ratio of the Agriculture value added per worker (constant 2005 US$) in Greece in 2002 to that in 2003?
Provide a succinct answer. 0.98. What is the ratio of the Agriculture value added per worker (constant 2005 US$) of Mauritius in 2002 to that in 2003?
Give a very brief answer. 0.95. What is the ratio of the Agriculture value added per worker (constant 2005 US$) in Low income in 2002 to that in 2004?
Keep it short and to the point. 1.02. What is the ratio of the Agriculture value added per worker (constant 2005 US$) of Greece in 2002 to that in 2004?
Keep it short and to the point. 0.95. What is the ratio of the Agriculture value added per worker (constant 2005 US$) of Mauritius in 2002 to that in 2004?
Your answer should be very brief. 0.81. What is the ratio of the Agriculture value added per worker (constant 2005 US$) of Low income in 2002 to that in 2005?
Keep it short and to the point. 0.92. What is the ratio of the Agriculture value added per worker (constant 2005 US$) in Greece in 2002 to that in 2005?
Keep it short and to the point. 0.89. What is the ratio of the Agriculture value added per worker (constant 2005 US$) of Mauritius in 2002 to that in 2005?
Keep it short and to the point. 0.84. What is the ratio of the Agriculture value added per worker (constant 2005 US$) of Low income in 2002 to that in 2006?
Provide a succinct answer. 0.97. What is the ratio of the Agriculture value added per worker (constant 2005 US$) of Greece in 2002 to that in 2006?
Provide a short and direct response. 1.01. What is the ratio of the Agriculture value added per worker (constant 2005 US$) of Mauritius in 2002 to that in 2006?
Offer a terse response. 0.82. What is the ratio of the Agriculture value added per worker (constant 2005 US$) of Low income in 2002 to that in 2007?
Keep it short and to the point. 0.95. What is the ratio of the Agriculture value added per worker (constant 2005 US$) of Greece in 2002 to that in 2007?
Your answer should be compact. 1.13. What is the ratio of the Agriculture value added per worker (constant 2005 US$) of Mauritius in 2002 to that in 2007?
Your response must be concise. 0.85. What is the ratio of the Agriculture value added per worker (constant 2005 US$) in Greece in 2003 to that in 2004?
Provide a succinct answer. 0.97. What is the ratio of the Agriculture value added per worker (constant 2005 US$) of Mauritius in 2003 to that in 2004?
Offer a very short reply. 0.85. What is the ratio of the Agriculture value added per worker (constant 2005 US$) in Low income in 2003 to that in 2005?
Offer a very short reply. 0.9. What is the ratio of the Agriculture value added per worker (constant 2005 US$) in Greece in 2003 to that in 2005?
Make the answer very short. 0.91. What is the ratio of the Agriculture value added per worker (constant 2005 US$) in Mauritius in 2003 to that in 2005?
Keep it short and to the point. 0.88. What is the ratio of the Agriculture value added per worker (constant 2005 US$) in Low income in 2003 to that in 2006?
Your response must be concise. 0.95. What is the ratio of the Agriculture value added per worker (constant 2005 US$) of Greece in 2003 to that in 2006?
Give a very brief answer. 1.03. What is the ratio of the Agriculture value added per worker (constant 2005 US$) in Mauritius in 2003 to that in 2006?
Give a very brief answer. 0.86. What is the ratio of the Agriculture value added per worker (constant 2005 US$) of Low income in 2003 to that in 2007?
Your answer should be compact. 0.94. What is the ratio of the Agriculture value added per worker (constant 2005 US$) of Greece in 2003 to that in 2007?
Ensure brevity in your answer.  1.15. What is the ratio of the Agriculture value added per worker (constant 2005 US$) of Mauritius in 2003 to that in 2007?
Make the answer very short. 0.89. What is the ratio of the Agriculture value added per worker (constant 2005 US$) of Low income in 2004 to that in 2005?
Your answer should be compact. 0.9. What is the ratio of the Agriculture value added per worker (constant 2005 US$) of Greece in 2004 to that in 2005?
Provide a succinct answer. 0.94. What is the ratio of the Agriculture value added per worker (constant 2005 US$) of Mauritius in 2004 to that in 2005?
Ensure brevity in your answer.  1.04. What is the ratio of the Agriculture value added per worker (constant 2005 US$) of Low income in 2004 to that in 2006?
Offer a very short reply. 0.95. What is the ratio of the Agriculture value added per worker (constant 2005 US$) in Greece in 2004 to that in 2006?
Ensure brevity in your answer.  1.06. What is the ratio of the Agriculture value added per worker (constant 2005 US$) in Mauritius in 2004 to that in 2006?
Provide a succinct answer. 1.01. What is the ratio of the Agriculture value added per worker (constant 2005 US$) of Low income in 2004 to that in 2007?
Provide a succinct answer. 0.94. What is the ratio of the Agriculture value added per worker (constant 2005 US$) of Greece in 2004 to that in 2007?
Your response must be concise. 1.19. What is the ratio of the Agriculture value added per worker (constant 2005 US$) of Mauritius in 2004 to that in 2007?
Make the answer very short. 1.05. What is the ratio of the Agriculture value added per worker (constant 2005 US$) of Low income in 2005 to that in 2006?
Your response must be concise. 1.06. What is the ratio of the Agriculture value added per worker (constant 2005 US$) in Greece in 2005 to that in 2006?
Give a very brief answer. 1.13. What is the ratio of the Agriculture value added per worker (constant 2005 US$) of Mauritius in 2005 to that in 2006?
Your answer should be compact. 0.98. What is the ratio of the Agriculture value added per worker (constant 2005 US$) in Low income in 2005 to that in 2007?
Offer a very short reply. 1.04. What is the ratio of the Agriculture value added per worker (constant 2005 US$) of Greece in 2005 to that in 2007?
Offer a very short reply. 1.27. What is the ratio of the Agriculture value added per worker (constant 2005 US$) of Mauritius in 2005 to that in 2007?
Provide a succinct answer. 1.01. What is the ratio of the Agriculture value added per worker (constant 2005 US$) of Low income in 2006 to that in 2007?
Make the answer very short. 0.98. What is the ratio of the Agriculture value added per worker (constant 2005 US$) in Greece in 2006 to that in 2007?
Offer a terse response. 1.12. What is the ratio of the Agriculture value added per worker (constant 2005 US$) of Mauritius in 2006 to that in 2007?
Provide a succinct answer. 1.03. What is the difference between the highest and the second highest Agriculture value added per worker (constant 2005 US$) in Low income?
Provide a succinct answer. 10.97. What is the difference between the highest and the second highest Agriculture value added per worker (constant 2005 US$) in Greece?
Give a very brief answer. 929.79. What is the difference between the highest and the second highest Agriculture value added per worker (constant 2005 US$) in Mauritius?
Your answer should be compact. 86.66. What is the difference between the highest and the lowest Agriculture value added per worker (constant 2005 US$) of Low income?
Give a very brief answer. 33.46. What is the difference between the highest and the lowest Agriculture value added per worker (constant 2005 US$) of Greece?
Make the answer very short. 3052.71. What is the difference between the highest and the lowest Agriculture value added per worker (constant 2005 US$) of Mauritius?
Offer a very short reply. 1193.15. 